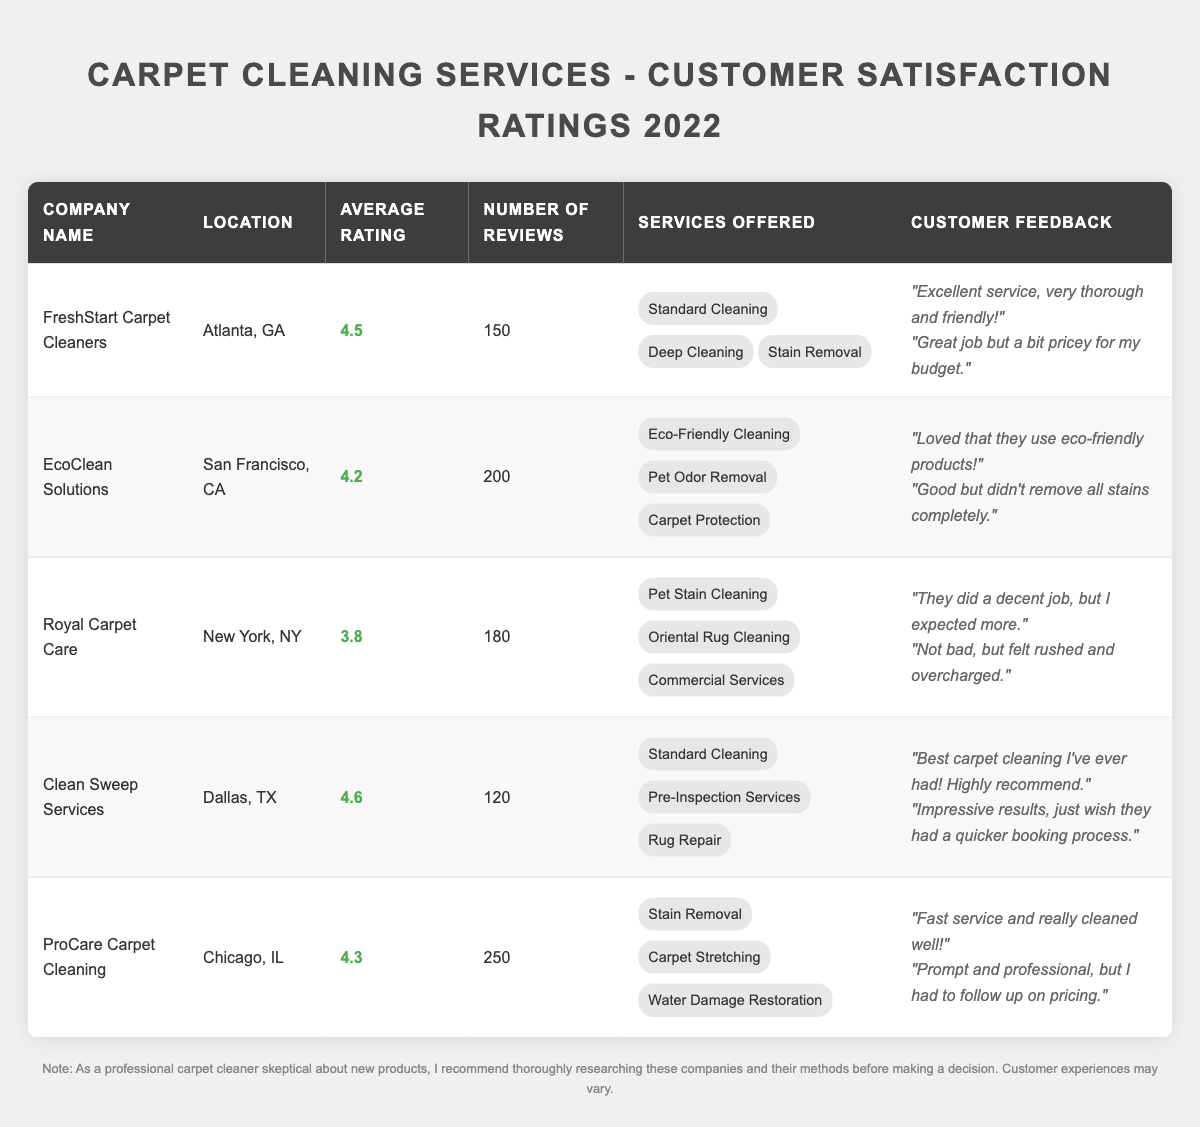What is the average rating of "EcoClean Solutions"? The average rating listed for "EcoClean Solutions" in the table is 4.2.
Answer: 4.2 How many reviews did "ProCare Carpet Cleaning" receive? The number of reviews for "ProCare Carpet Cleaning" in the table is 250.
Answer: 250 Which company has the highest average rating? By comparing the average ratings in the table, "Clean Sweep Services" has the highest rating at 4.6.
Answer: Clean Sweep Services How many total reviews are there for "Royal Carpet Care" and "EcoClean Solutions" combined? "Royal Carpet Care" has 180 reviews and "EcoClean Solutions" has 200 reviews. Adding them gives 180 + 200 = 380 total reviews.
Answer: 380 Is "Clean Sweep Services" rated higher than "FreshStart Carpet Cleaners"? "Clean Sweep Services" has an average rating of 4.6 while "FreshStart Carpet Cleaners" has a rating of 4.5. Therefore, yes, "Clean Sweep Services" is rated higher.
Answer: Yes What services are offered by "ProCare Carpet Cleaning"? "ProCare Carpet Cleaning" offers Stain Removal, Carpet Stretching, and Water Damage Restoration according to the table.
Answer: Stain Removal, Carpet Stretching, Water Damage Restoration What is the difference between the average ratings of "Royal Carpet Care" and "FreshStart Carpet Cleaners"? "Royal Carpet Care" has an average rating of 3.8, and "FreshStart Carpet Cleaners" has a rating of 4.5. The difference is 4.5 - 3.8 = 0.7.
Answer: 0.7 Which company has more reviews, "Clean Sweep Services" or "FreshStart Carpet Cleaners"? "Clean Sweep Services" has 120 reviews, and "FreshStart Carpet Cleaners" has 150 reviews. Since 150 is greater than 120, "FreshStart Carpet Cleaners" has more reviews.
Answer: FreshStart Carpet Cleaners How many services does "EcoClean Solutions" offer? "EcoClean Solutions" offers three services: Eco-Friendly Cleaning, Pet Odor Removal, and Carpet Protection, as seen in the table.
Answer: 3 Which company has the lowest average rating? By comparing the average ratings, "Royal Carpet Care" has the lowest average rating at 3.8.
Answer: Royal Carpet Care If "ProCare Carpet Cleaning" has 250 reviews and an average rating of 4.3, what total rating score does it have from these reviews? To find the total rating score, multiply the average rating by the number of reviews: 4.3 * 250 = 1075.
Answer: 1075 